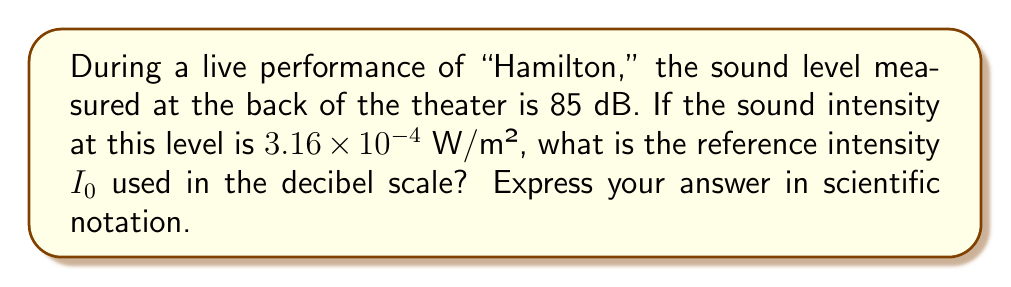Solve this math problem. Let's approach this step-by-step:

1) The decibel level is given by the formula:

   $$ \text{dB} = 10 \log_{10}\left(\frac{I}{I_0}\right) $$

   Where $I$ is the measured intensity and $I_0$ is the reference intensity.

2) We're given:
   - dB = 85
   - $I = 3.16 \times 10^{-4}$ W/m²

3) Let's substitute these into our equation:

   $$ 85 = 10 \log_{10}\left(\frac{3.16 \times 10^{-4}}{I_0}\right) $$

4) Divide both sides by 10:

   $$ 8.5 = \log_{10}\left(\frac{3.16 \times 10^{-4}}{I_0}\right) $$

5) Now, we can use the definition of logarithms to rewrite this as:

   $$ 10^{8.5} = \frac{3.16 \times 10^{-4}}{I_0} $$

6) Calculate $10^{8.5}$:

   $$ 3.16 \times 10^8 = \frac{3.16 \times 10^{-4}}{I_0} $$

7) Now, we can solve for $I_0$:

   $$ I_0 = \frac{3.16 \times 10^{-4}}{3.16 \times 10^8} = 10^{-12} \text{ W/m²} $$
Answer: $10^{-12}$ W/m² 